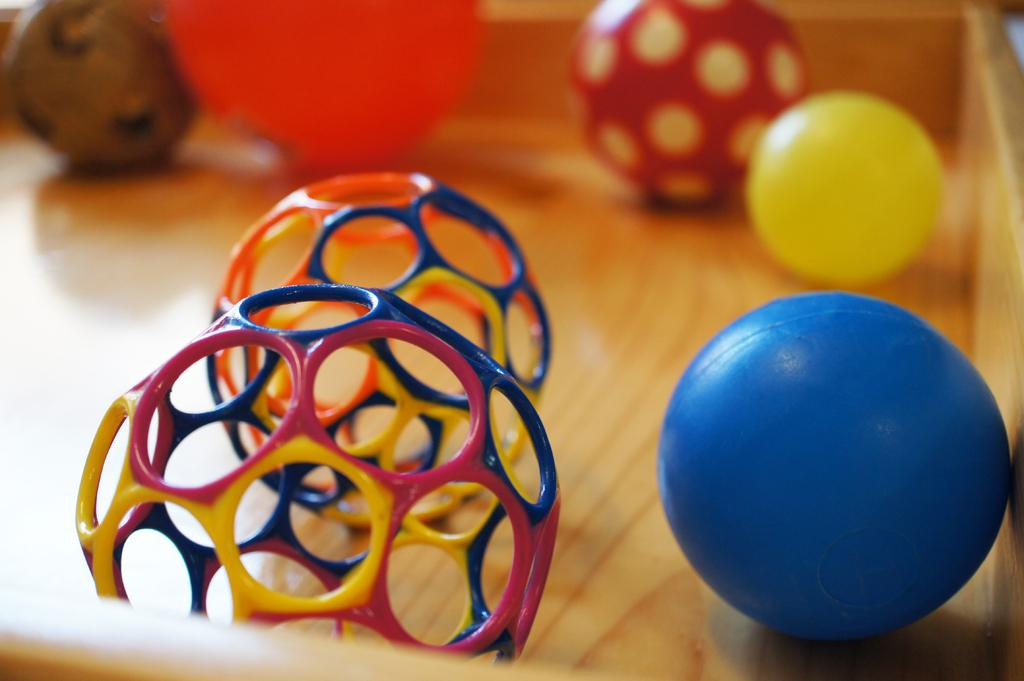What type of objects can be seen in the image? There are balls in the image. Are there any other objects present besides the balls? Yes, there are other objects in the image. What type of surface is visible in the image? The wooden surface is present in the image. What type of impulse can be seen affecting the balls in the image? There is no impulse affecting the balls in the image; they are stationary. Can you tell me how many guitars are present in the image? There is no guitar present in the image. 